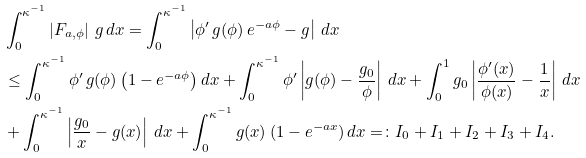<formula> <loc_0><loc_0><loc_500><loc_500>& \int _ { 0 } ^ { \kappa ^ { - 1 } } \left | F _ { a , \phi } \right | \, g \, d x = \int _ { 0 } ^ { \kappa ^ { - 1 } } \left | \phi ^ { \prime } \, g ( \phi ) \, e ^ { - a \phi } - g \right | \, d x \\ & \leq \int _ { 0 } ^ { \kappa ^ { - 1 } } \phi ^ { \prime } \, g ( \phi ) \left ( 1 - e ^ { - a \phi } \right ) d x + \int _ { 0 } ^ { \kappa ^ { - 1 } } \phi ^ { \prime } \left | g ( \phi ) - \frac { g _ { 0 } } { \phi } \right | \, d x + \int _ { 0 } ^ { 1 } g _ { 0 } \left | \frac { \phi ^ { \prime } ( x ) } { \phi ( x ) } - \frac { 1 } { x } \right | \, d x \\ & + \int _ { 0 } ^ { \kappa ^ { - 1 } } \left | \frac { g _ { 0 } } x - g ( x ) \right | \, d x + \int _ { 0 } ^ { \kappa ^ { - 1 } } g ( x ) \, ( 1 - e ^ { - a x } ) \, d x = \colon I _ { 0 } + I _ { 1 } + I _ { 2 } + I _ { 3 } + I _ { 4 } .</formula> 